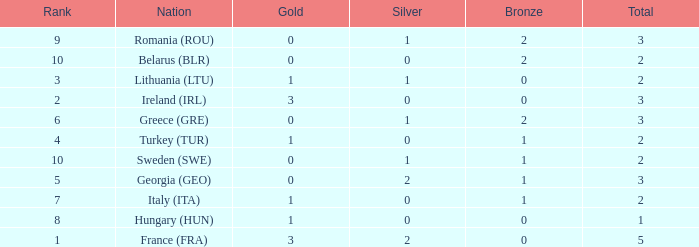What's the total of rank 8 when Silver medals are 0 and gold is more than 1? 0.0. 